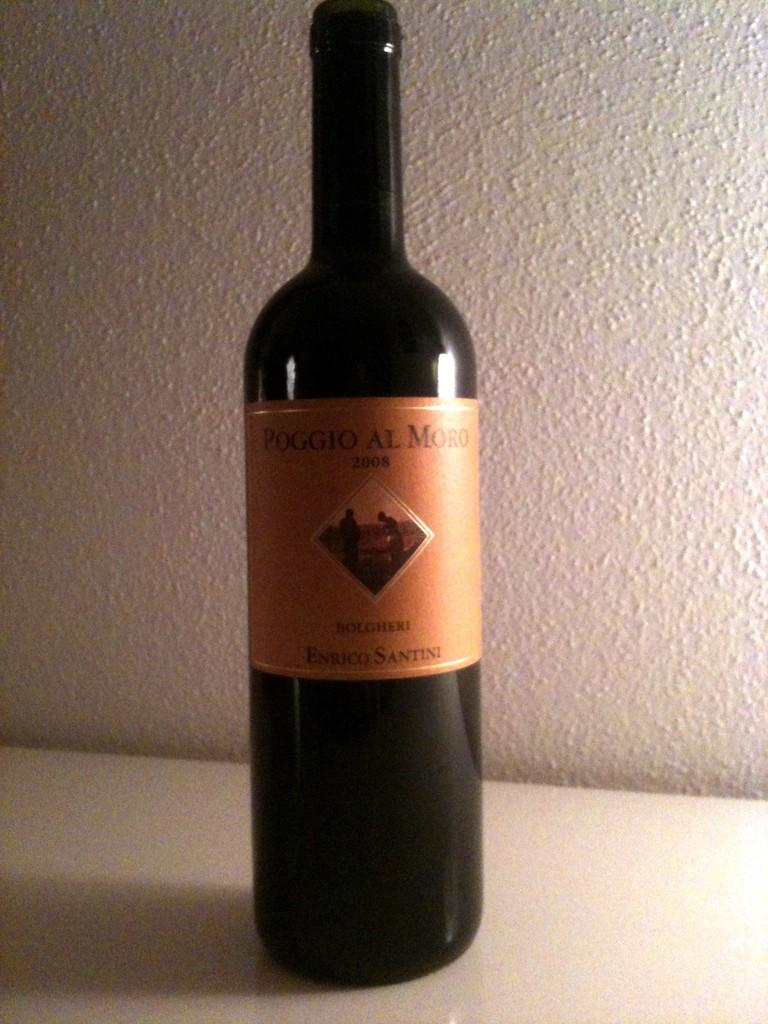<image>
Share a concise interpretation of the image provided. A bottle of Poggio Al Moro sits on a white countertop. 